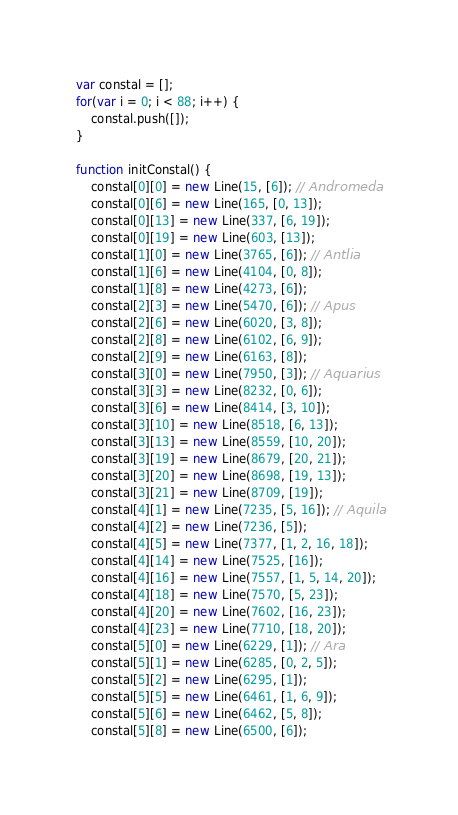<code> <loc_0><loc_0><loc_500><loc_500><_JavaScript_>var constal = [];
for(var i = 0; i < 88; i++) {
    constal.push([]);
}

function initConstal() {
    constal[0][0] = new Line(15, [6]); // Andromeda
    constal[0][6] = new Line(165, [0, 13]);
    constal[0][13] = new Line(337, [6, 19]);
    constal[0][19] = new Line(603, [13]);
    constal[1][0] = new Line(3765, [6]); // Antlia
    constal[1][6] = new Line(4104, [0, 8]);
    constal[1][8] = new Line(4273, [6]);
    constal[2][3] = new Line(5470, [6]); // Apus
    constal[2][6] = new Line(6020, [3, 8]);
    constal[2][8] = new Line(6102, [6, 9]);
    constal[2][9] = new Line(6163, [8]);
    constal[3][0] = new Line(7950, [3]); // Aquarius
    constal[3][3] = new Line(8232, [0, 6]);
    constal[3][6] = new Line(8414, [3, 10]);
    constal[3][10] = new Line(8518, [6, 13]);
    constal[3][13] = new Line(8559, [10, 20]);
    constal[3][19] = new Line(8679, [20, 21]);
    constal[3][20] = new Line(8698, [19, 13]);
    constal[3][21] = new Line(8709, [19]);
    constal[4][1] = new Line(7235, [5, 16]); // Aquila
    constal[4][2] = new Line(7236, [5]);
    constal[4][5] = new Line(7377, [1, 2, 16, 18]);
    constal[4][14] = new Line(7525, [16]);
    constal[4][16] = new Line(7557, [1, 5, 14, 20]);
    constal[4][18] = new Line(7570, [5, 23]);
    constal[4][20] = new Line(7602, [16, 23]);
    constal[4][23] = new Line(7710, [18, 20]);
    constal[5][0] = new Line(6229, [1]); // Ara
    constal[5][1] = new Line(6285, [0, 2, 5]);
    constal[5][2] = new Line(6295, [1]);
    constal[5][5] = new Line(6461, [1, 6, 9]);
    constal[5][6] = new Line(6462, [5, 8]);
    constal[5][8] = new Line(6500, [6]);</code> 